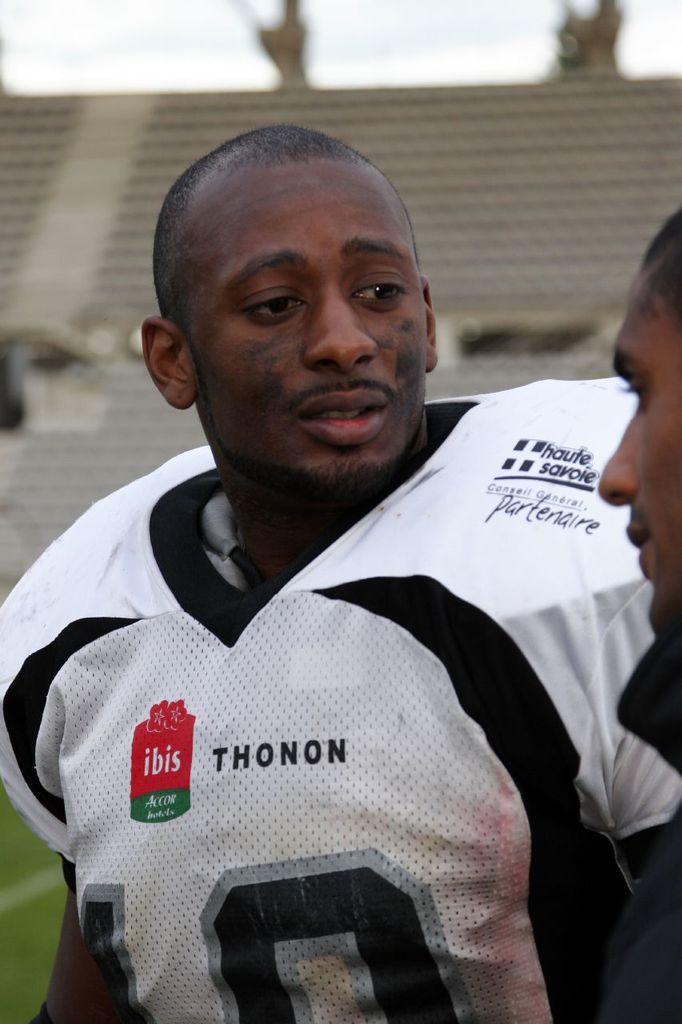What is the name of the team on his football shirt?
Your response must be concise. Thonon. Who has the team partnered with?
Offer a terse response. Ibis. 